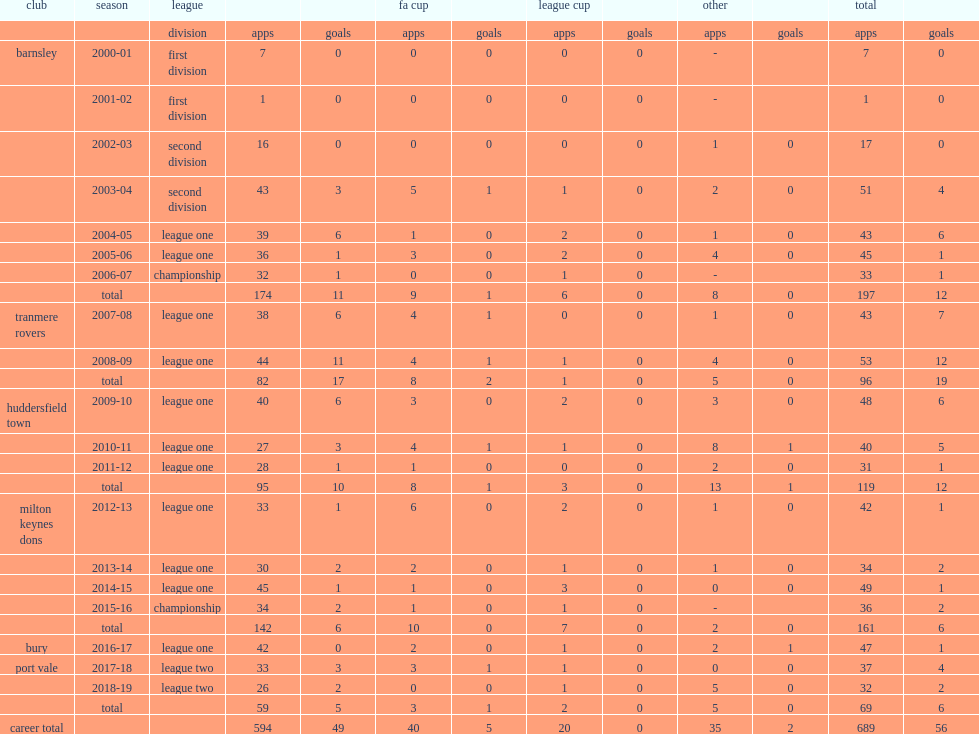Which club did antony kay play for in 2012-13? Milton keynes dons. Could you help me parse every detail presented in this table? {'header': ['club', 'season', 'league', '', '', 'fa cup', '', 'league cup', '', 'other', '', 'total', ''], 'rows': [['', '', 'division', 'apps', 'goals', 'apps', 'goals', 'apps', 'goals', 'apps', 'goals', 'apps', 'goals'], ['barnsley', '2000-01', 'first division', '7', '0', '0', '0', '0', '0', '-', '', '7', '0'], ['', '2001-02', 'first division', '1', '0', '0', '0', '0', '0', '-', '', '1', '0'], ['', '2002-03', 'second division', '16', '0', '0', '0', '0', '0', '1', '0', '17', '0'], ['', '2003-04', 'second division', '43', '3', '5', '1', '1', '0', '2', '0', '51', '4'], ['', '2004-05', 'league one', '39', '6', '1', '0', '2', '0', '1', '0', '43', '6'], ['', '2005-06', 'league one', '36', '1', '3', '0', '2', '0', '4', '0', '45', '1'], ['', '2006-07', 'championship', '32', '1', '0', '0', '1', '0', '-', '', '33', '1'], ['', 'total', '', '174', '11', '9', '1', '6', '0', '8', '0', '197', '12'], ['tranmere rovers', '2007-08', 'league one', '38', '6', '4', '1', '0', '0', '1', '0', '43', '7'], ['', '2008-09', 'league one', '44', '11', '4', '1', '1', '0', '4', '0', '53', '12'], ['', 'total', '', '82', '17', '8', '2', '1', '0', '5', '0', '96', '19'], ['huddersfield town', '2009-10', 'league one', '40', '6', '3', '0', '2', '0', '3', '0', '48', '6'], ['', '2010-11', 'league one', '27', '3', '4', '1', '1', '0', '8', '1', '40', '5'], ['', '2011-12', 'league one', '28', '1', '1', '0', '0', '0', '2', '0', '31', '1'], ['', 'total', '', '95', '10', '8', '1', '3', '0', '13', '1', '119', '12'], ['milton keynes dons', '2012-13', 'league one', '33', '1', '6', '0', '2', '0', '1', '0', '42', '1'], ['', '2013-14', 'league one', '30', '2', '2', '0', '1', '0', '1', '0', '34', '2'], ['', '2014-15', 'league one', '45', '1', '1', '0', '3', '0', '0', '0', '49', '1'], ['', '2015-16', 'championship', '34', '2', '1', '0', '1', '0', '-', '', '36', '2'], ['', 'total', '', '142', '6', '10', '0', '7', '0', '2', '0', '161', '6'], ['bury', '2016-17', 'league one', '42', '0', '2', '0', '1', '0', '2', '1', '47', '1'], ['port vale', '2017-18', 'league two', '33', '3', '3', '1', '1', '0', '0', '0', '37', '4'], ['', '2018-19', 'league two', '26', '2', '0', '0', '1', '0', '5', '0', '32', '2'], ['', 'total', '', '59', '5', '3', '1', '2', '0', '5', '0', '69', '6'], ['career total', '', '', '594', '49', '40', '5', '20', '0', '35', '2', '689', '56']]} 